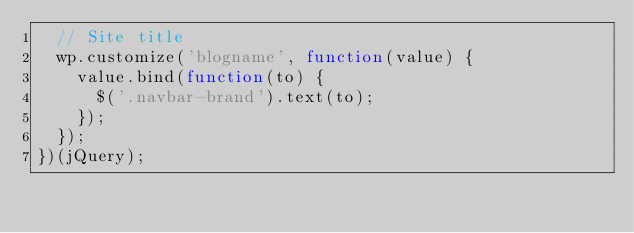<code> <loc_0><loc_0><loc_500><loc_500><_JavaScript_>  // Site title
  wp.customize('blogname', function(value) {
    value.bind(function(to) {
      $('.navbar-brand').text(to);
    });
  });
})(jQuery);
</code> 